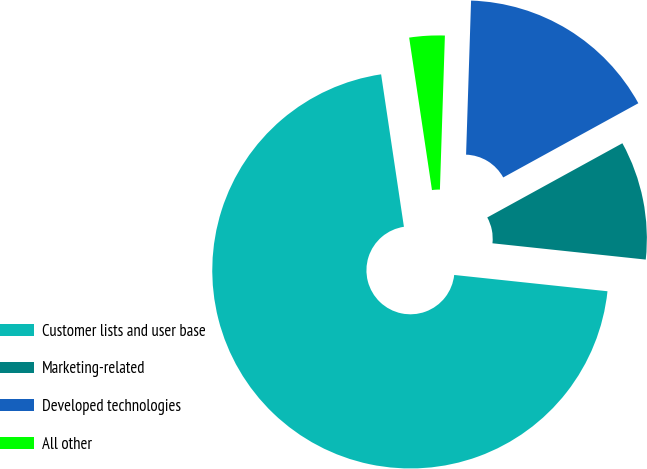Convert chart to OTSL. <chart><loc_0><loc_0><loc_500><loc_500><pie_chart><fcel>Customer lists and user base<fcel>Marketing-related<fcel>Developed technologies<fcel>All other<nl><fcel>70.95%<fcel>9.68%<fcel>16.49%<fcel>2.88%<nl></chart> 